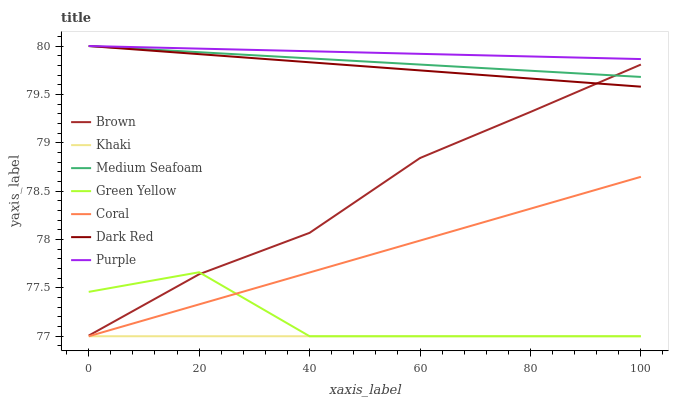Does Khaki have the minimum area under the curve?
Answer yes or no. Yes. Does Purple have the maximum area under the curve?
Answer yes or no. Yes. Does Purple have the minimum area under the curve?
Answer yes or no. No. Does Khaki have the maximum area under the curve?
Answer yes or no. No. Is Khaki the smoothest?
Answer yes or no. Yes. Is Green Yellow the roughest?
Answer yes or no. Yes. Is Purple the smoothest?
Answer yes or no. No. Is Purple the roughest?
Answer yes or no. No. Does Khaki have the lowest value?
Answer yes or no. Yes. Does Purple have the lowest value?
Answer yes or no. No. Does Medium Seafoam have the highest value?
Answer yes or no. Yes. Does Khaki have the highest value?
Answer yes or no. No. Is Khaki less than Brown?
Answer yes or no. Yes. Is Medium Seafoam greater than Green Yellow?
Answer yes or no. Yes. Does Dark Red intersect Brown?
Answer yes or no. Yes. Is Dark Red less than Brown?
Answer yes or no. No. Is Dark Red greater than Brown?
Answer yes or no. No. Does Khaki intersect Brown?
Answer yes or no. No. 